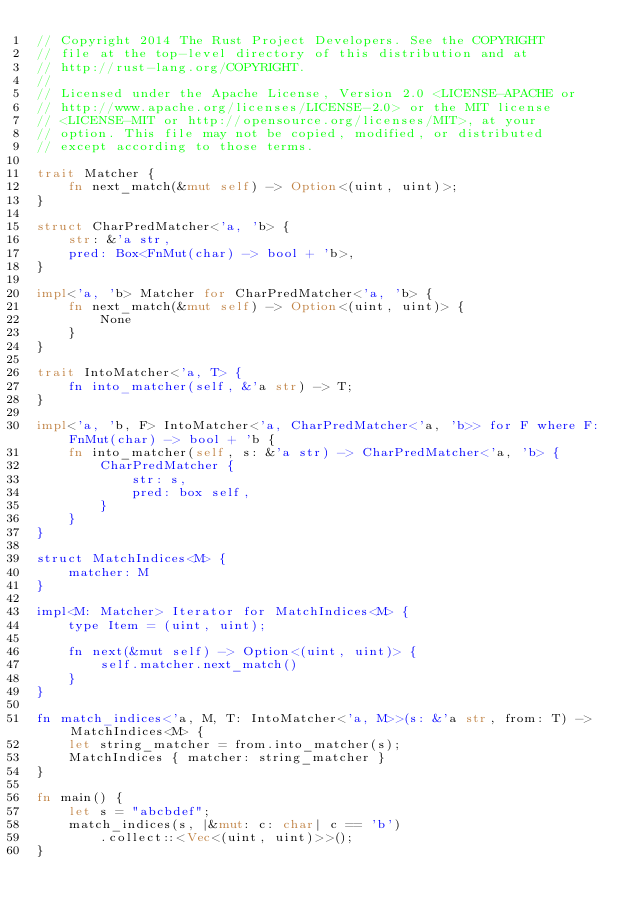Convert code to text. <code><loc_0><loc_0><loc_500><loc_500><_Rust_>// Copyright 2014 The Rust Project Developers. See the COPYRIGHT
// file at the top-level directory of this distribution and at
// http://rust-lang.org/COPYRIGHT.
//
// Licensed under the Apache License, Version 2.0 <LICENSE-APACHE or
// http://www.apache.org/licenses/LICENSE-2.0> or the MIT license
// <LICENSE-MIT or http://opensource.org/licenses/MIT>, at your
// option. This file may not be copied, modified, or distributed
// except according to those terms.

trait Matcher {
    fn next_match(&mut self) -> Option<(uint, uint)>;
}

struct CharPredMatcher<'a, 'b> {
    str: &'a str,
    pred: Box<FnMut(char) -> bool + 'b>,
}

impl<'a, 'b> Matcher for CharPredMatcher<'a, 'b> {
    fn next_match(&mut self) -> Option<(uint, uint)> {
        None
    }
}

trait IntoMatcher<'a, T> {
    fn into_matcher(self, &'a str) -> T;
}

impl<'a, 'b, F> IntoMatcher<'a, CharPredMatcher<'a, 'b>> for F where F: FnMut(char) -> bool + 'b {
    fn into_matcher(self, s: &'a str) -> CharPredMatcher<'a, 'b> {
        CharPredMatcher {
            str: s,
            pred: box self,
        }
    }
}

struct MatchIndices<M> {
    matcher: M
}

impl<M: Matcher> Iterator for MatchIndices<M> {
    type Item = (uint, uint);

    fn next(&mut self) -> Option<(uint, uint)> {
        self.matcher.next_match()
    }
}

fn match_indices<'a, M, T: IntoMatcher<'a, M>>(s: &'a str, from: T) -> MatchIndices<M> {
    let string_matcher = from.into_matcher(s);
    MatchIndices { matcher: string_matcher }
}

fn main() {
    let s = "abcbdef";
    match_indices(s, |&mut: c: char| c == 'b')
        .collect::<Vec<(uint, uint)>>();
}
</code> 